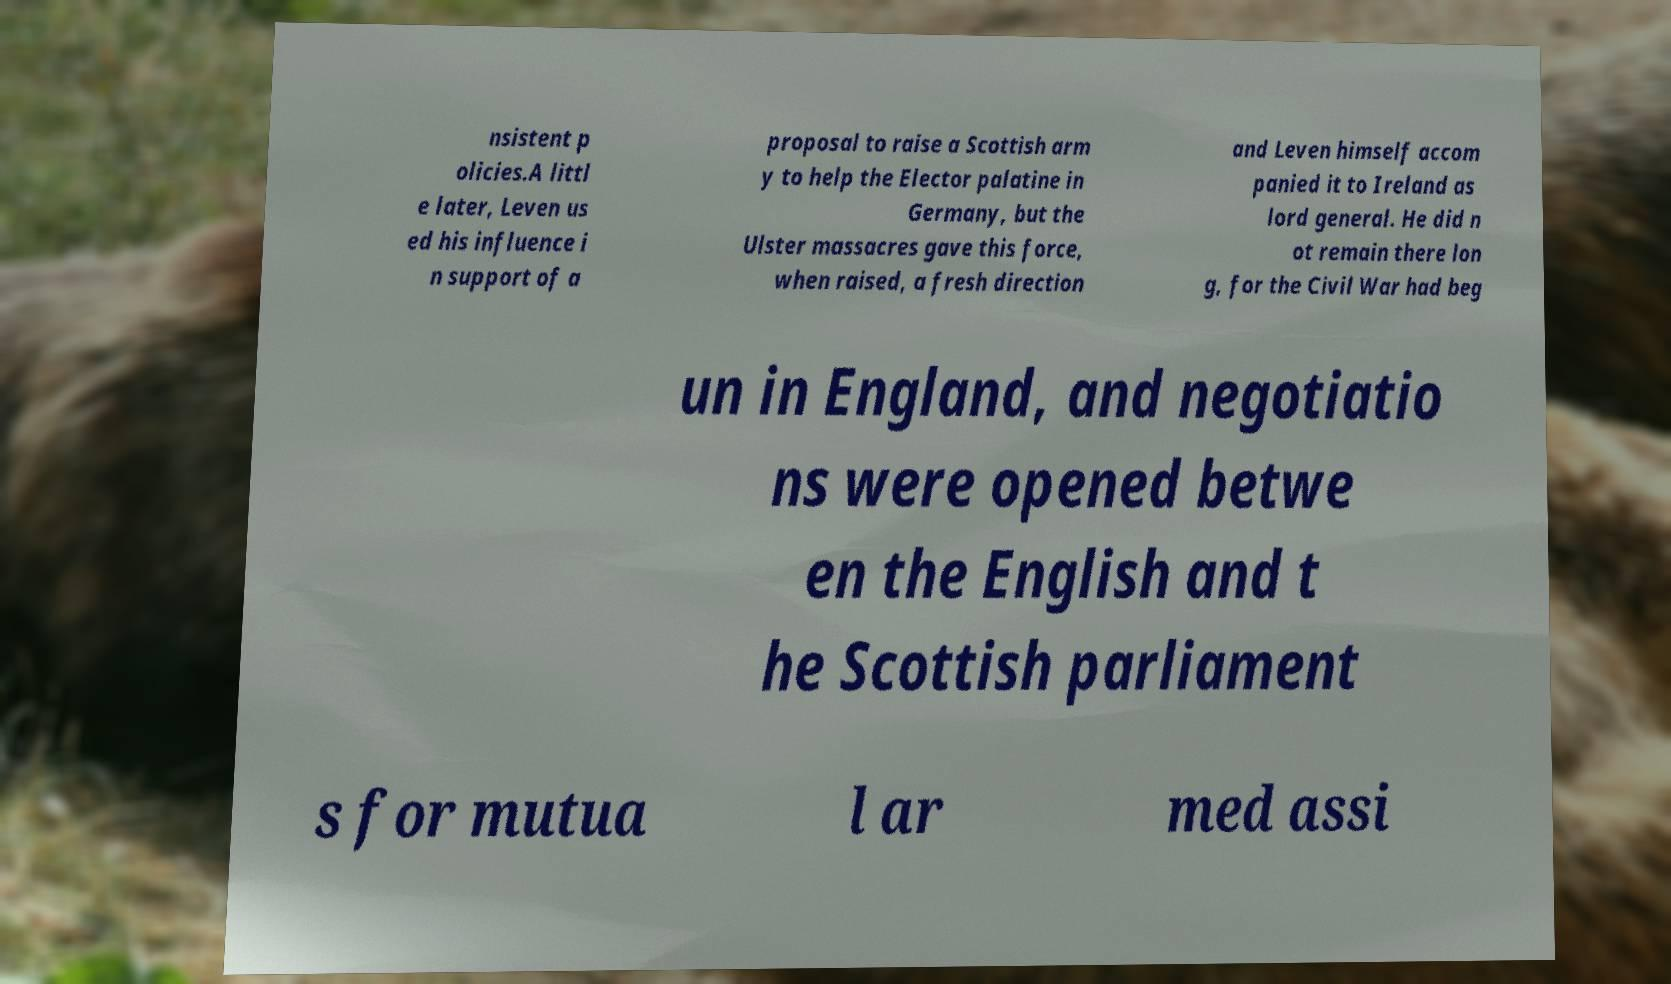Could you assist in decoding the text presented in this image and type it out clearly? nsistent p olicies.A littl e later, Leven us ed his influence i n support of a proposal to raise a Scottish arm y to help the Elector palatine in Germany, but the Ulster massacres gave this force, when raised, a fresh direction and Leven himself accom panied it to Ireland as lord general. He did n ot remain there lon g, for the Civil War had beg un in England, and negotiatio ns were opened betwe en the English and t he Scottish parliament s for mutua l ar med assi 